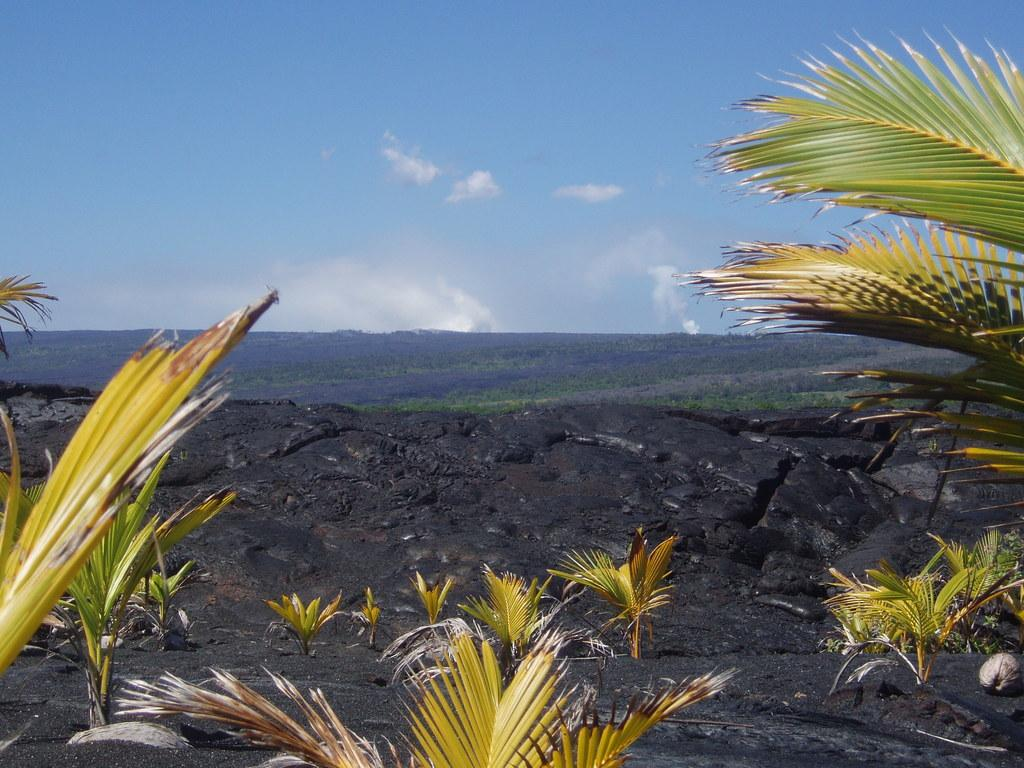What color is the ground in the image? The ground in the image is black. What type of vegetation can be seen in the image? There are plants and grass in the image. What is on the ground in the image? There are objects on the ground. What can be seen above the ground in the image? The sky is visible in the image, and clouds are present in the sky. Can you tell me where the kettle is located in the image? There is no kettle present in the image. What type of chess pieces can be seen playing a game in the image? There is no chess game or pieces present in the image. 